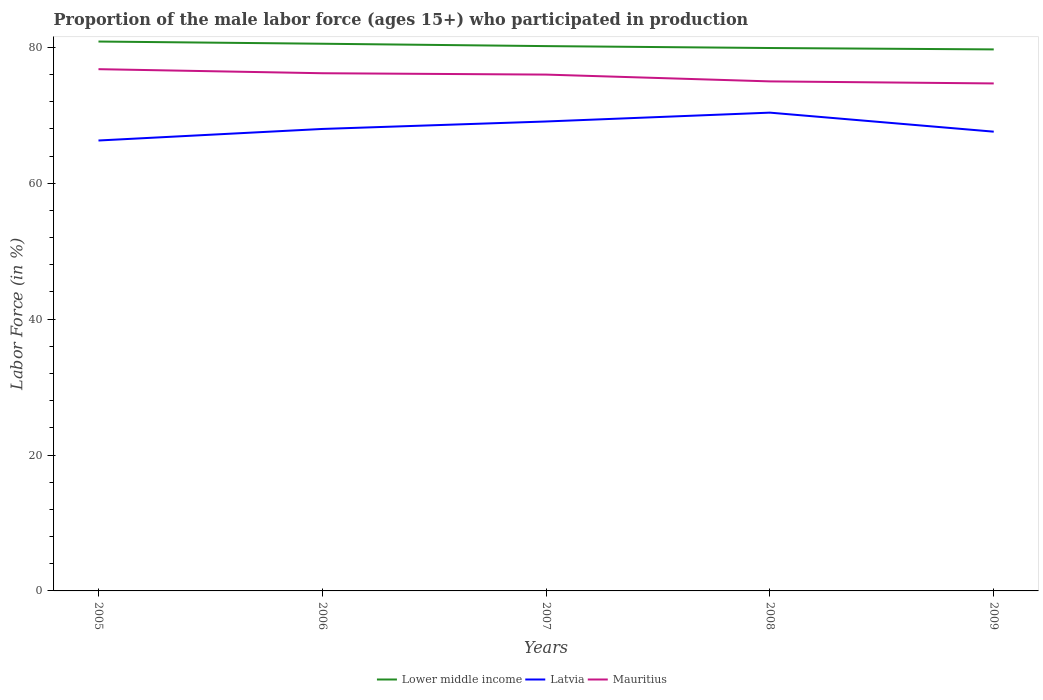Does the line corresponding to Lower middle income intersect with the line corresponding to Latvia?
Give a very brief answer. No. Across all years, what is the maximum proportion of the male labor force who participated in production in Lower middle income?
Offer a terse response. 79.71. What is the total proportion of the male labor force who participated in production in Latvia in the graph?
Offer a terse response. -2.8. What is the difference between the highest and the second highest proportion of the male labor force who participated in production in Lower middle income?
Ensure brevity in your answer.  1.16. What is the difference between the highest and the lowest proportion of the male labor force who participated in production in Lower middle income?
Your answer should be compact. 2. How many years are there in the graph?
Ensure brevity in your answer.  5. What is the difference between two consecutive major ticks on the Y-axis?
Offer a terse response. 20. Are the values on the major ticks of Y-axis written in scientific E-notation?
Provide a succinct answer. No. Does the graph contain any zero values?
Ensure brevity in your answer.  No. Does the graph contain grids?
Your answer should be very brief. No. Where does the legend appear in the graph?
Provide a succinct answer. Bottom center. What is the title of the graph?
Your answer should be compact. Proportion of the male labor force (ages 15+) who participated in production. What is the Labor Force (in %) of Lower middle income in 2005?
Offer a very short reply. 80.87. What is the Labor Force (in %) of Latvia in 2005?
Provide a succinct answer. 66.3. What is the Labor Force (in %) of Mauritius in 2005?
Offer a very short reply. 76.8. What is the Labor Force (in %) of Lower middle income in 2006?
Keep it short and to the point. 80.54. What is the Labor Force (in %) in Latvia in 2006?
Keep it short and to the point. 68. What is the Labor Force (in %) in Mauritius in 2006?
Offer a very short reply. 76.2. What is the Labor Force (in %) of Lower middle income in 2007?
Provide a short and direct response. 80.19. What is the Labor Force (in %) in Latvia in 2007?
Provide a short and direct response. 69.1. What is the Labor Force (in %) of Mauritius in 2007?
Ensure brevity in your answer.  76. What is the Labor Force (in %) of Lower middle income in 2008?
Your response must be concise. 79.91. What is the Labor Force (in %) in Latvia in 2008?
Ensure brevity in your answer.  70.4. What is the Labor Force (in %) in Mauritius in 2008?
Give a very brief answer. 75. What is the Labor Force (in %) of Lower middle income in 2009?
Provide a short and direct response. 79.71. What is the Labor Force (in %) in Latvia in 2009?
Make the answer very short. 67.6. What is the Labor Force (in %) in Mauritius in 2009?
Your answer should be very brief. 74.7. Across all years, what is the maximum Labor Force (in %) in Lower middle income?
Offer a very short reply. 80.87. Across all years, what is the maximum Labor Force (in %) of Latvia?
Provide a short and direct response. 70.4. Across all years, what is the maximum Labor Force (in %) in Mauritius?
Offer a very short reply. 76.8. Across all years, what is the minimum Labor Force (in %) in Lower middle income?
Provide a succinct answer. 79.71. Across all years, what is the minimum Labor Force (in %) in Latvia?
Offer a very short reply. 66.3. Across all years, what is the minimum Labor Force (in %) in Mauritius?
Your response must be concise. 74.7. What is the total Labor Force (in %) of Lower middle income in the graph?
Offer a terse response. 401.23. What is the total Labor Force (in %) in Latvia in the graph?
Make the answer very short. 341.4. What is the total Labor Force (in %) in Mauritius in the graph?
Your answer should be very brief. 378.7. What is the difference between the Labor Force (in %) in Lower middle income in 2005 and that in 2006?
Your answer should be compact. 0.33. What is the difference between the Labor Force (in %) in Lower middle income in 2005 and that in 2007?
Make the answer very short. 0.68. What is the difference between the Labor Force (in %) of Mauritius in 2005 and that in 2007?
Offer a very short reply. 0.8. What is the difference between the Labor Force (in %) in Lower middle income in 2005 and that in 2008?
Your response must be concise. 0.96. What is the difference between the Labor Force (in %) in Lower middle income in 2005 and that in 2009?
Give a very brief answer. 1.16. What is the difference between the Labor Force (in %) in Mauritius in 2005 and that in 2009?
Offer a terse response. 2.1. What is the difference between the Labor Force (in %) of Lower middle income in 2006 and that in 2007?
Give a very brief answer. 0.35. What is the difference between the Labor Force (in %) of Lower middle income in 2006 and that in 2008?
Provide a short and direct response. 0.63. What is the difference between the Labor Force (in %) of Latvia in 2006 and that in 2008?
Offer a very short reply. -2.4. What is the difference between the Labor Force (in %) in Lower middle income in 2006 and that in 2009?
Keep it short and to the point. 0.83. What is the difference between the Labor Force (in %) of Latvia in 2006 and that in 2009?
Your answer should be very brief. 0.4. What is the difference between the Labor Force (in %) of Lower middle income in 2007 and that in 2008?
Your response must be concise. 0.28. What is the difference between the Labor Force (in %) of Latvia in 2007 and that in 2008?
Offer a terse response. -1.3. What is the difference between the Labor Force (in %) in Lower middle income in 2007 and that in 2009?
Provide a succinct answer. 0.48. What is the difference between the Labor Force (in %) of Mauritius in 2007 and that in 2009?
Offer a very short reply. 1.3. What is the difference between the Labor Force (in %) of Lower middle income in 2008 and that in 2009?
Offer a very short reply. 0.2. What is the difference between the Labor Force (in %) of Latvia in 2008 and that in 2009?
Offer a terse response. 2.8. What is the difference between the Labor Force (in %) in Lower middle income in 2005 and the Labor Force (in %) in Latvia in 2006?
Your answer should be compact. 12.87. What is the difference between the Labor Force (in %) of Lower middle income in 2005 and the Labor Force (in %) of Mauritius in 2006?
Offer a very short reply. 4.67. What is the difference between the Labor Force (in %) of Latvia in 2005 and the Labor Force (in %) of Mauritius in 2006?
Ensure brevity in your answer.  -9.9. What is the difference between the Labor Force (in %) of Lower middle income in 2005 and the Labor Force (in %) of Latvia in 2007?
Provide a short and direct response. 11.77. What is the difference between the Labor Force (in %) of Lower middle income in 2005 and the Labor Force (in %) of Mauritius in 2007?
Make the answer very short. 4.87. What is the difference between the Labor Force (in %) of Latvia in 2005 and the Labor Force (in %) of Mauritius in 2007?
Offer a very short reply. -9.7. What is the difference between the Labor Force (in %) of Lower middle income in 2005 and the Labor Force (in %) of Latvia in 2008?
Make the answer very short. 10.47. What is the difference between the Labor Force (in %) in Lower middle income in 2005 and the Labor Force (in %) in Mauritius in 2008?
Offer a terse response. 5.87. What is the difference between the Labor Force (in %) of Lower middle income in 2005 and the Labor Force (in %) of Latvia in 2009?
Offer a terse response. 13.27. What is the difference between the Labor Force (in %) of Lower middle income in 2005 and the Labor Force (in %) of Mauritius in 2009?
Offer a very short reply. 6.17. What is the difference between the Labor Force (in %) of Latvia in 2005 and the Labor Force (in %) of Mauritius in 2009?
Keep it short and to the point. -8.4. What is the difference between the Labor Force (in %) of Lower middle income in 2006 and the Labor Force (in %) of Latvia in 2007?
Your answer should be compact. 11.44. What is the difference between the Labor Force (in %) in Lower middle income in 2006 and the Labor Force (in %) in Mauritius in 2007?
Your answer should be very brief. 4.54. What is the difference between the Labor Force (in %) in Lower middle income in 2006 and the Labor Force (in %) in Latvia in 2008?
Provide a short and direct response. 10.14. What is the difference between the Labor Force (in %) of Lower middle income in 2006 and the Labor Force (in %) of Mauritius in 2008?
Make the answer very short. 5.54. What is the difference between the Labor Force (in %) of Lower middle income in 2006 and the Labor Force (in %) of Latvia in 2009?
Keep it short and to the point. 12.94. What is the difference between the Labor Force (in %) of Lower middle income in 2006 and the Labor Force (in %) of Mauritius in 2009?
Provide a succinct answer. 5.84. What is the difference between the Labor Force (in %) in Latvia in 2006 and the Labor Force (in %) in Mauritius in 2009?
Provide a short and direct response. -6.7. What is the difference between the Labor Force (in %) of Lower middle income in 2007 and the Labor Force (in %) of Latvia in 2008?
Ensure brevity in your answer.  9.79. What is the difference between the Labor Force (in %) of Lower middle income in 2007 and the Labor Force (in %) of Mauritius in 2008?
Give a very brief answer. 5.19. What is the difference between the Labor Force (in %) of Lower middle income in 2007 and the Labor Force (in %) of Latvia in 2009?
Your answer should be very brief. 12.59. What is the difference between the Labor Force (in %) of Lower middle income in 2007 and the Labor Force (in %) of Mauritius in 2009?
Provide a short and direct response. 5.49. What is the difference between the Labor Force (in %) in Lower middle income in 2008 and the Labor Force (in %) in Latvia in 2009?
Offer a terse response. 12.31. What is the difference between the Labor Force (in %) in Lower middle income in 2008 and the Labor Force (in %) in Mauritius in 2009?
Your answer should be compact. 5.21. What is the average Labor Force (in %) in Lower middle income per year?
Offer a terse response. 80.25. What is the average Labor Force (in %) in Latvia per year?
Offer a very short reply. 68.28. What is the average Labor Force (in %) of Mauritius per year?
Provide a succinct answer. 75.74. In the year 2005, what is the difference between the Labor Force (in %) of Lower middle income and Labor Force (in %) of Latvia?
Give a very brief answer. 14.57. In the year 2005, what is the difference between the Labor Force (in %) of Lower middle income and Labor Force (in %) of Mauritius?
Your answer should be very brief. 4.07. In the year 2006, what is the difference between the Labor Force (in %) of Lower middle income and Labor Force (in %) of Latvia?
Give a very brief answer. 12.54. In the year 2006, what is the difference between the Labor Force (in %) of Lower middle income and Labor Force (in %) of Mauritius?
Make the answer very short. 4.34. In the year 2007, what is the difference between the Labor Force (in %) in Lower middle income and Labor Force (in %) in Latvia?
Keep it short and to the point. 11.09. In the year 2007, what is the difference between the Labor Force (in %) of Lower middle income and Labor Force (in %) of Mauritius?
Your answer should be compact. 4.19. In the year 2007, what is the difference between the Labor Force (in %) of Latvia and Labor Force (in %) of Mauritius?
Offer a very short reply. -6.9. In the year 2008, what is the difference between the Labor Force (in %) of Lower middle income and Labor Force (in %) of Latvia?
Make the answer very short. 9.51. In the year 2008, what is the difference between the Labor Force (in %) of Lower middle income and Labor Force (in %) of Mauritius?
Make the answer very short. 4.91. In the year 2008, what is the difference between the Labor Force (in %) in Latvia and Labor Force (in %) in Mauritius?
Make the answer very short. -4.6. In the year 2009, what is the difference between the Labor Force (in %) of Lower middle income and Labor Force (in %) of Latvia?
Make the answer very short. 12.11. In the year 2009, what is the difference between the Labor Force (in %) in Lower middle income and Labor Force (in %) in Mauritius?
Ensure brevity in your answer.  5.01. In the year 2009, what is the difference between the Labor Force (in %) in Latvia and Labor Force (in %) in Mauritius?
Keep it short and to the point. -7.1. What is the ratio of the Labor Force (in %) in Lower middle income in 2005 to that in 2006?
Your answer should be very brief. 1. What is the ratio of the Labor Force (in %) of Mauritius in 2005 to that in 2006?
Give a very brief answer. 1.01. What is the ratio of the Labor Force (in %) in Lower middle income in 2005 to that in 2007?
Provide a succinct answer. 1.01. What is the ratio of the Labor Force (in %) of Latvia in 2005 to that in 2007?
Your response must be concise. 0.96. What is the ratio of the Labor Force (in %) of Mauritius in 2005 to that in 2007?
Provide a short and direct response. 1.01. What is the ratio of the Labor Force (in %) in Lower middle income in 2005 to that in 2008?
Offer a very short reply. 1.01. What is the ratio of the Labor Force (in %) of Latvia in 2005 to that in 2008?
Offer a very short reply. 0.94. What is the ratio of the Labor Force (in %) in Lower middle income in 2005 to that in 2009?
Offer a terse response. 1.01. What is the ratio of the Labor Force (in %) of Latvia in 2005 to that in 2009?
Offer a terse response. 0.98. What is the ratio of the Labor Force (in %) of Mauritius in 2005 to that in 2009?
Provide a succinct answer. 1.03. What is the ratio of the Labor Force (in %) of Latvia in 2006 to that in 2007?
Offer a terse response. 0.98. What is the ratio of the Labor Force (in %) of Lower middle income in 2006 to that in 2008?
Give a very brief answer. 1.01. What is the ratio of the Labor Force (in %) in Latvia in 2006 to that in 2008?
Give a very brief answer. 0.97. What is the ratio of the Labor Force (in %) of Lower middle income in 2006 to that in 2009?
Your answer should be compact. 1.01. What is the ratio of the Labor Force (in %) in Latvia in 2006 to that in 2009?
Offer a terse response. 1.01. What is the ratio of the Labor Force (in %) of Mauritius in 2006 to that in 2009?
Your response must be concise. 1.02. What is the ratio of the Labor Force (in %) of Latvia in 2007 to that in 2008?
Your response must be concise. 0.98. What is the ratio of the Labor Force (in %) of Mauritius in 2007 to that in 2008?
Your answer should be very brief. 1.01. What is the ratio of the Labor Force (in %) of Latvia in 2007 to that in 2009?
Provide a short and direct response. 1.02. What is the ratio of the Labor Force (in %) in Mauritius in 2007 to that in 2009?
Ensure brevity in your answer.  1.02. What is the ratio of the Labor Force (in %) of Latvia in 2008 to that in 2009?
Offer a very short reply. 1.04. What is the difference between the highest and the second highest Labor Force (in %) in Lower middle income?
Give a very brief answer. 0.33. What is the difference between the highest and the second highest Labor Force (in %) of Latvia?
Offer a very short reply. 1.3. What is the difference between the highest and the second highest Labor Force (in %) in Mauritius?
Provide a short and direct response. 0.6. What is the difference between the highest and the lowest Labor Force (in %) in Lower middle income?
Offer a terse response. 1.16. 